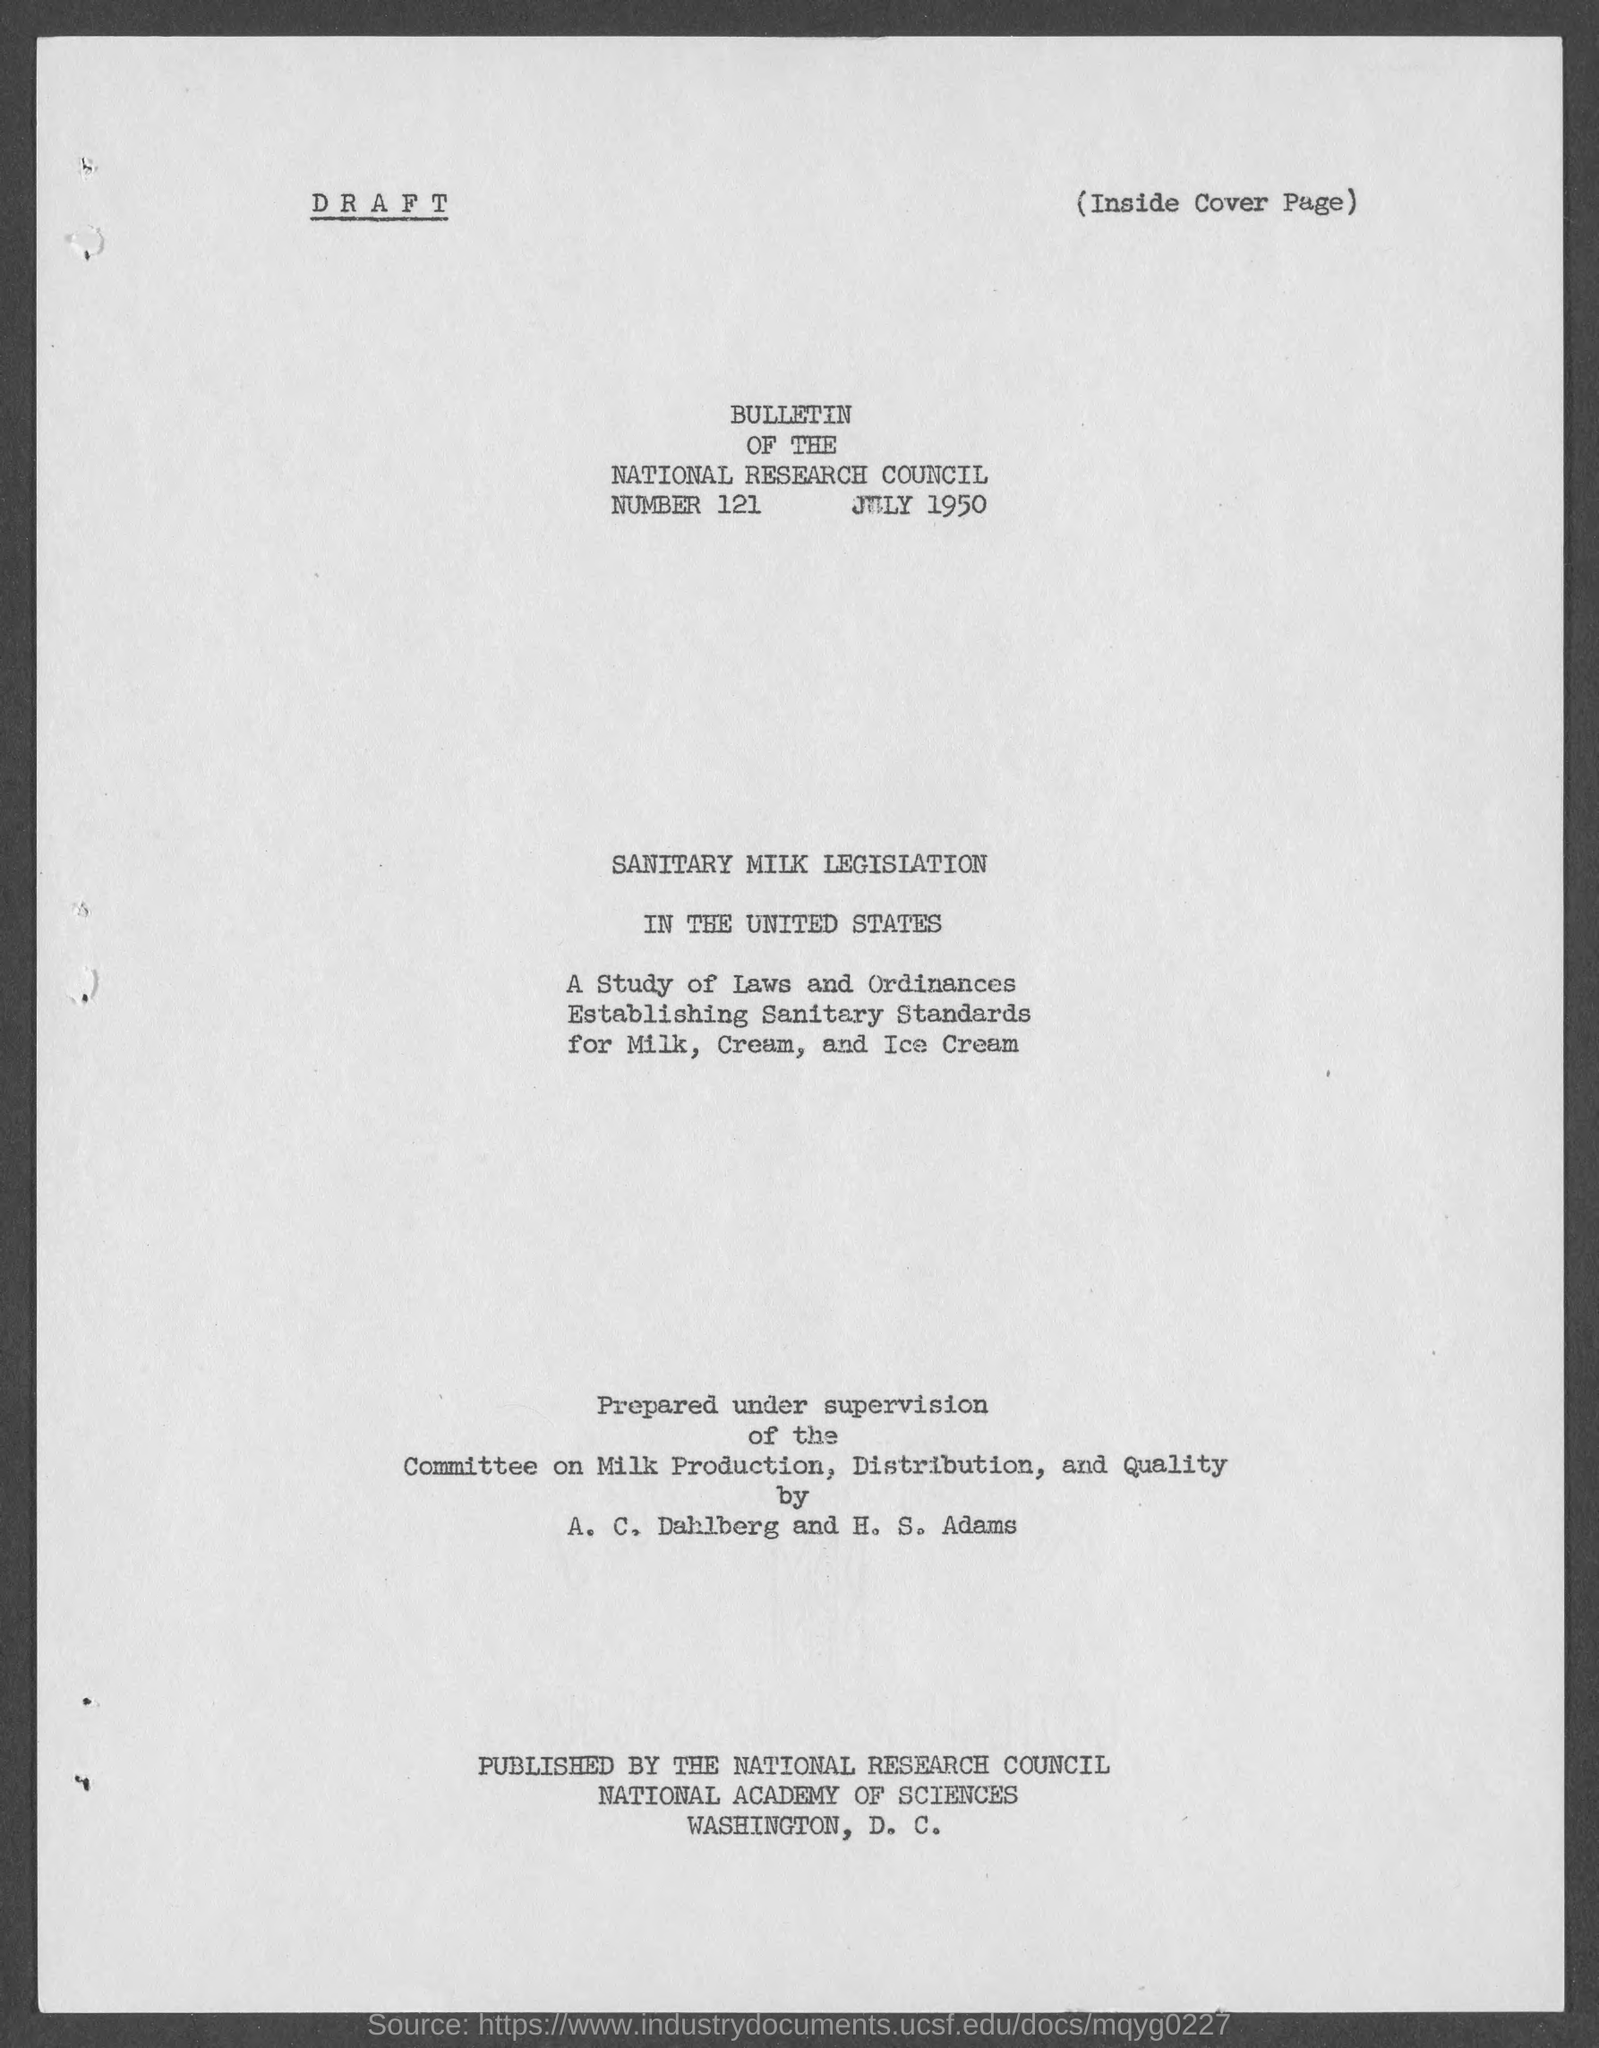Specify some key components in this picture. The title of the document is the Bulletin of the National Research Council. The document mentions that the date is July 1950. 